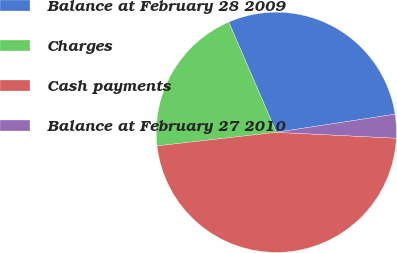Convert chart to OTSL. <chart><loc_0><loc_0><loc_500><loc_500><pie_chart><fcel>Balance at February 28 2009<fcel>Charges<fcel>Cash payments<fcel>Balance at February 27 2010<nl><fcel>29.08%<fcel>20.32%<fcel>47.41%<fcel>3.19%<nl></chart> 